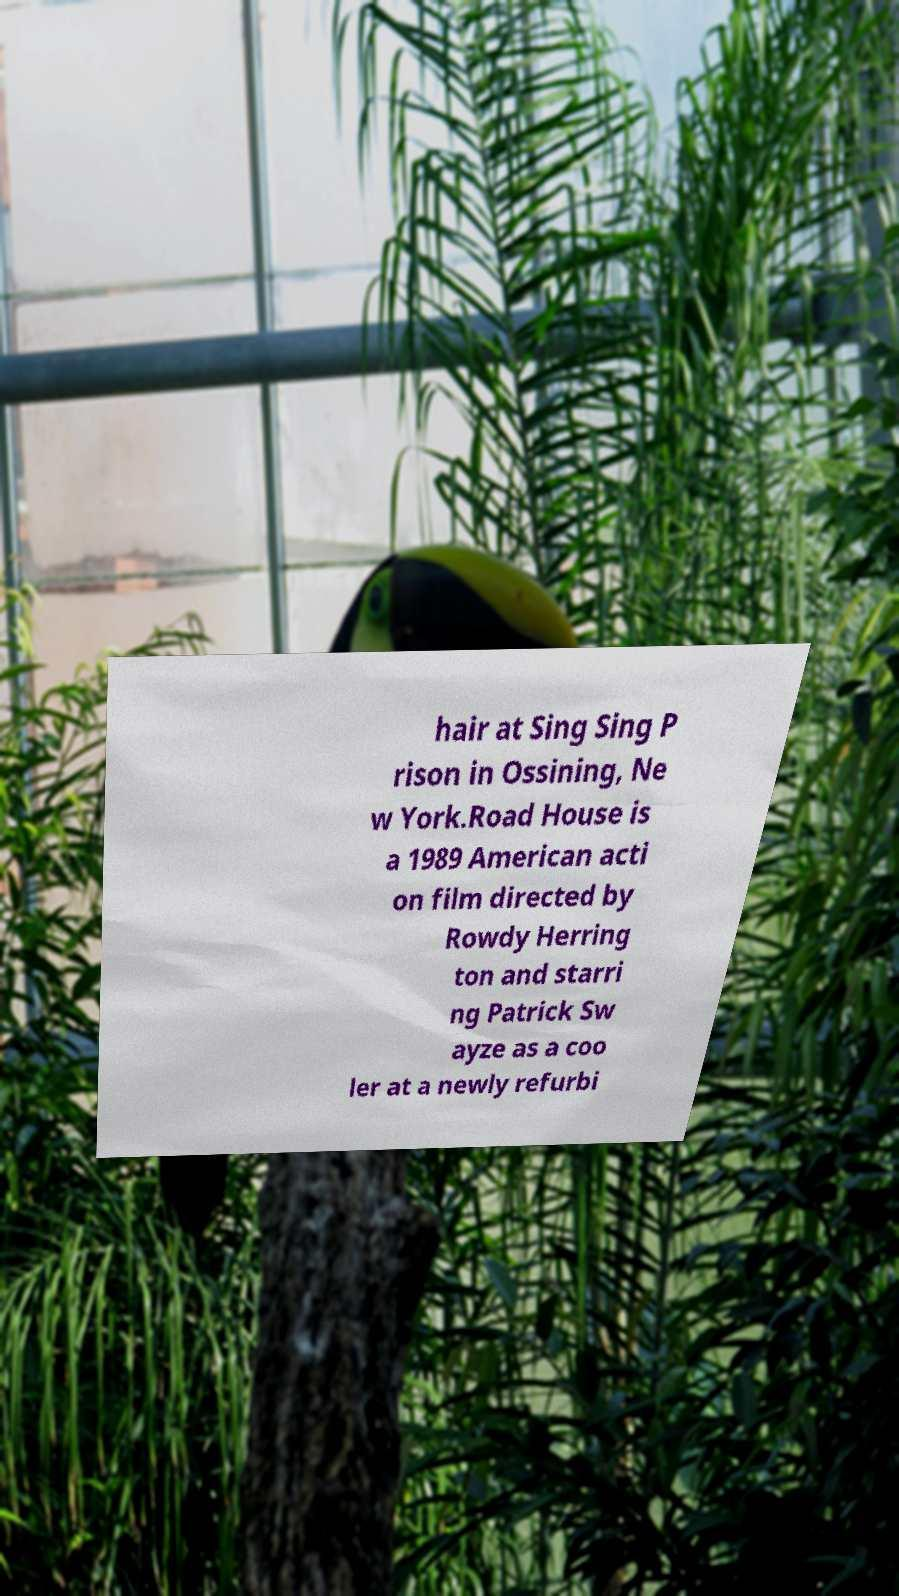For documentation purposes, I need the text within this image transcribed. Could you provide that? hair at Sing Sing P rison in Ossining, Ne w York.Road House is a 1989 American acti on film directed by Rowdy Herring ton and starri ng Patrick Sw ayze as a coo ler at a newly refurbi 